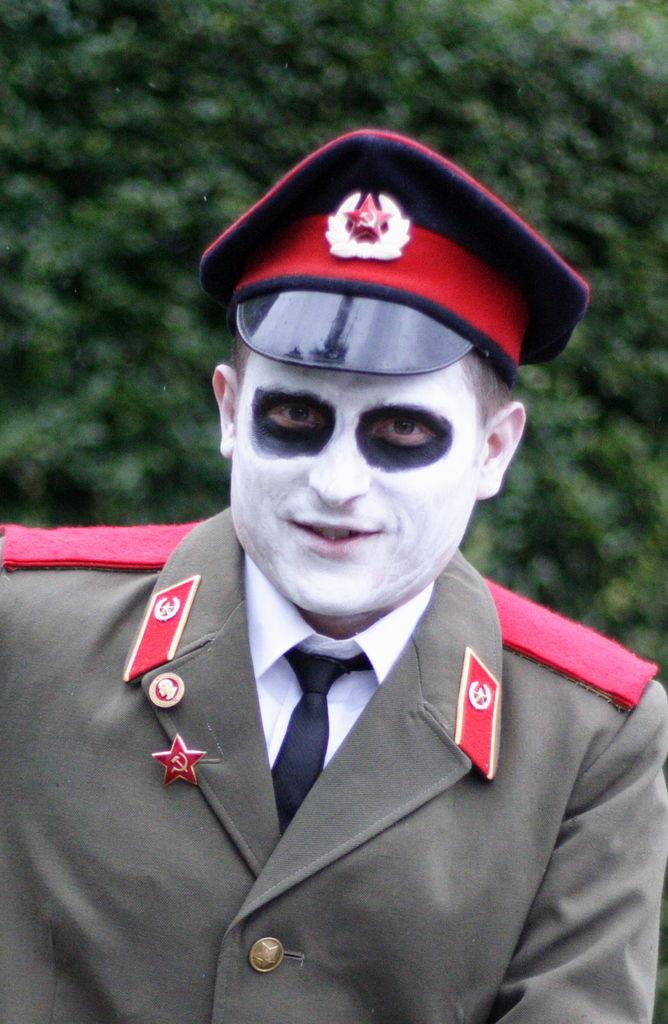Who is the main subject in the front of the image? There is a man in the front of the image. What can be seen in the background of the image? There is a tree in the background of the image. What type of furniture is being offered by the man in the image? There is no furniture present in the image, and the man is not offering anything. 